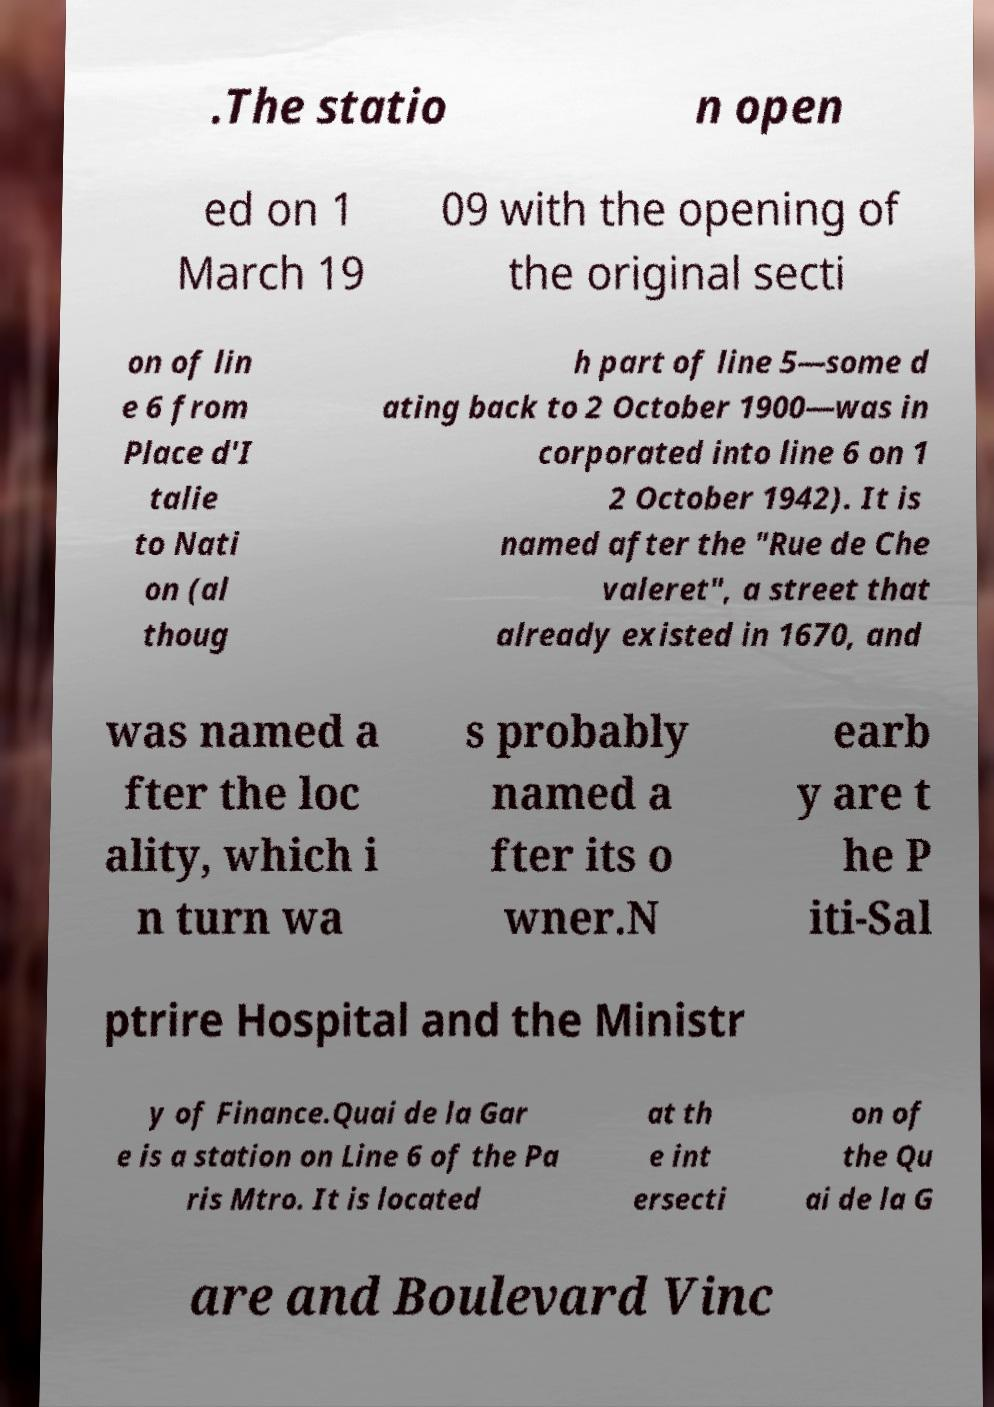I need the written content from this picture converted into text. Can you do that? .The statio n open ed on 1 March 19 09 with the opening of the original secti on of lin e 6 from Place d'I talie to Nati on (al thoug h part of line 5—some d ating back to 2 October 1900—was in corporated into line 6 on 1 2 October 1942). It is named after the "Rue de Che valeret", a street that already existed in 1670, and was named a fter the loc ality, which i n turn wa s probably named a fter its o wner.N earb y are t he P iti-Sal ptrire Hospital and the Ministr y of Finance.Quai de la Gar e is a station on Line 6 of the Pa ris Mtro. It is located at th e int ersecti on of the Qu ai de la G are and Boulevard Vinc 